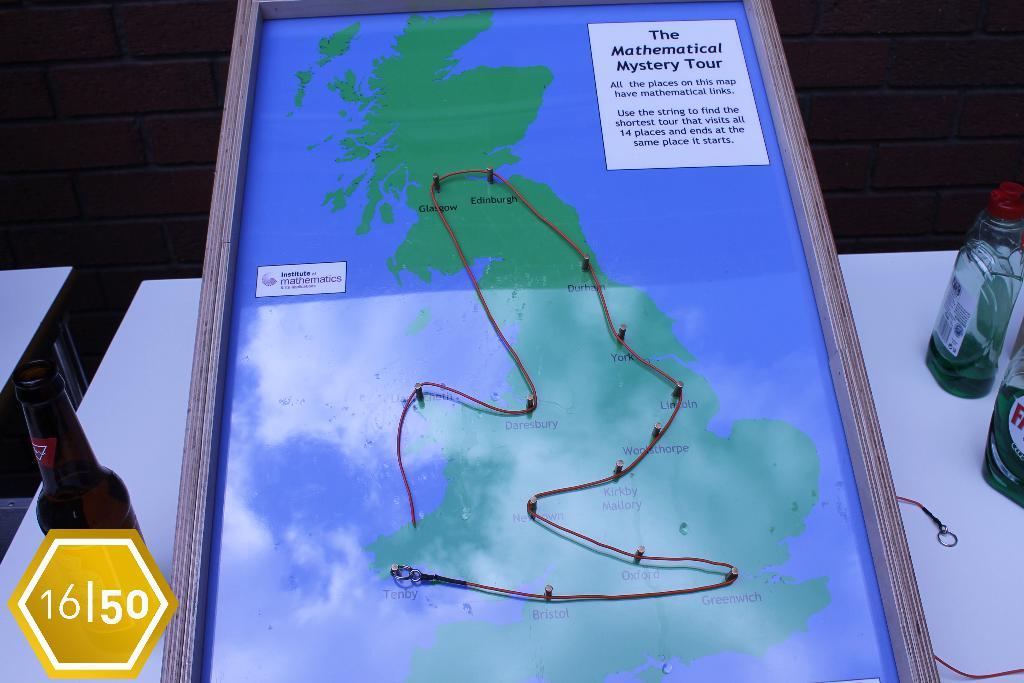What is this a map of?
Your answer should be very brief. The mathematical mystery tour. What kind of links does the places on the map have?
Your answer should be compact. Mathematical. 